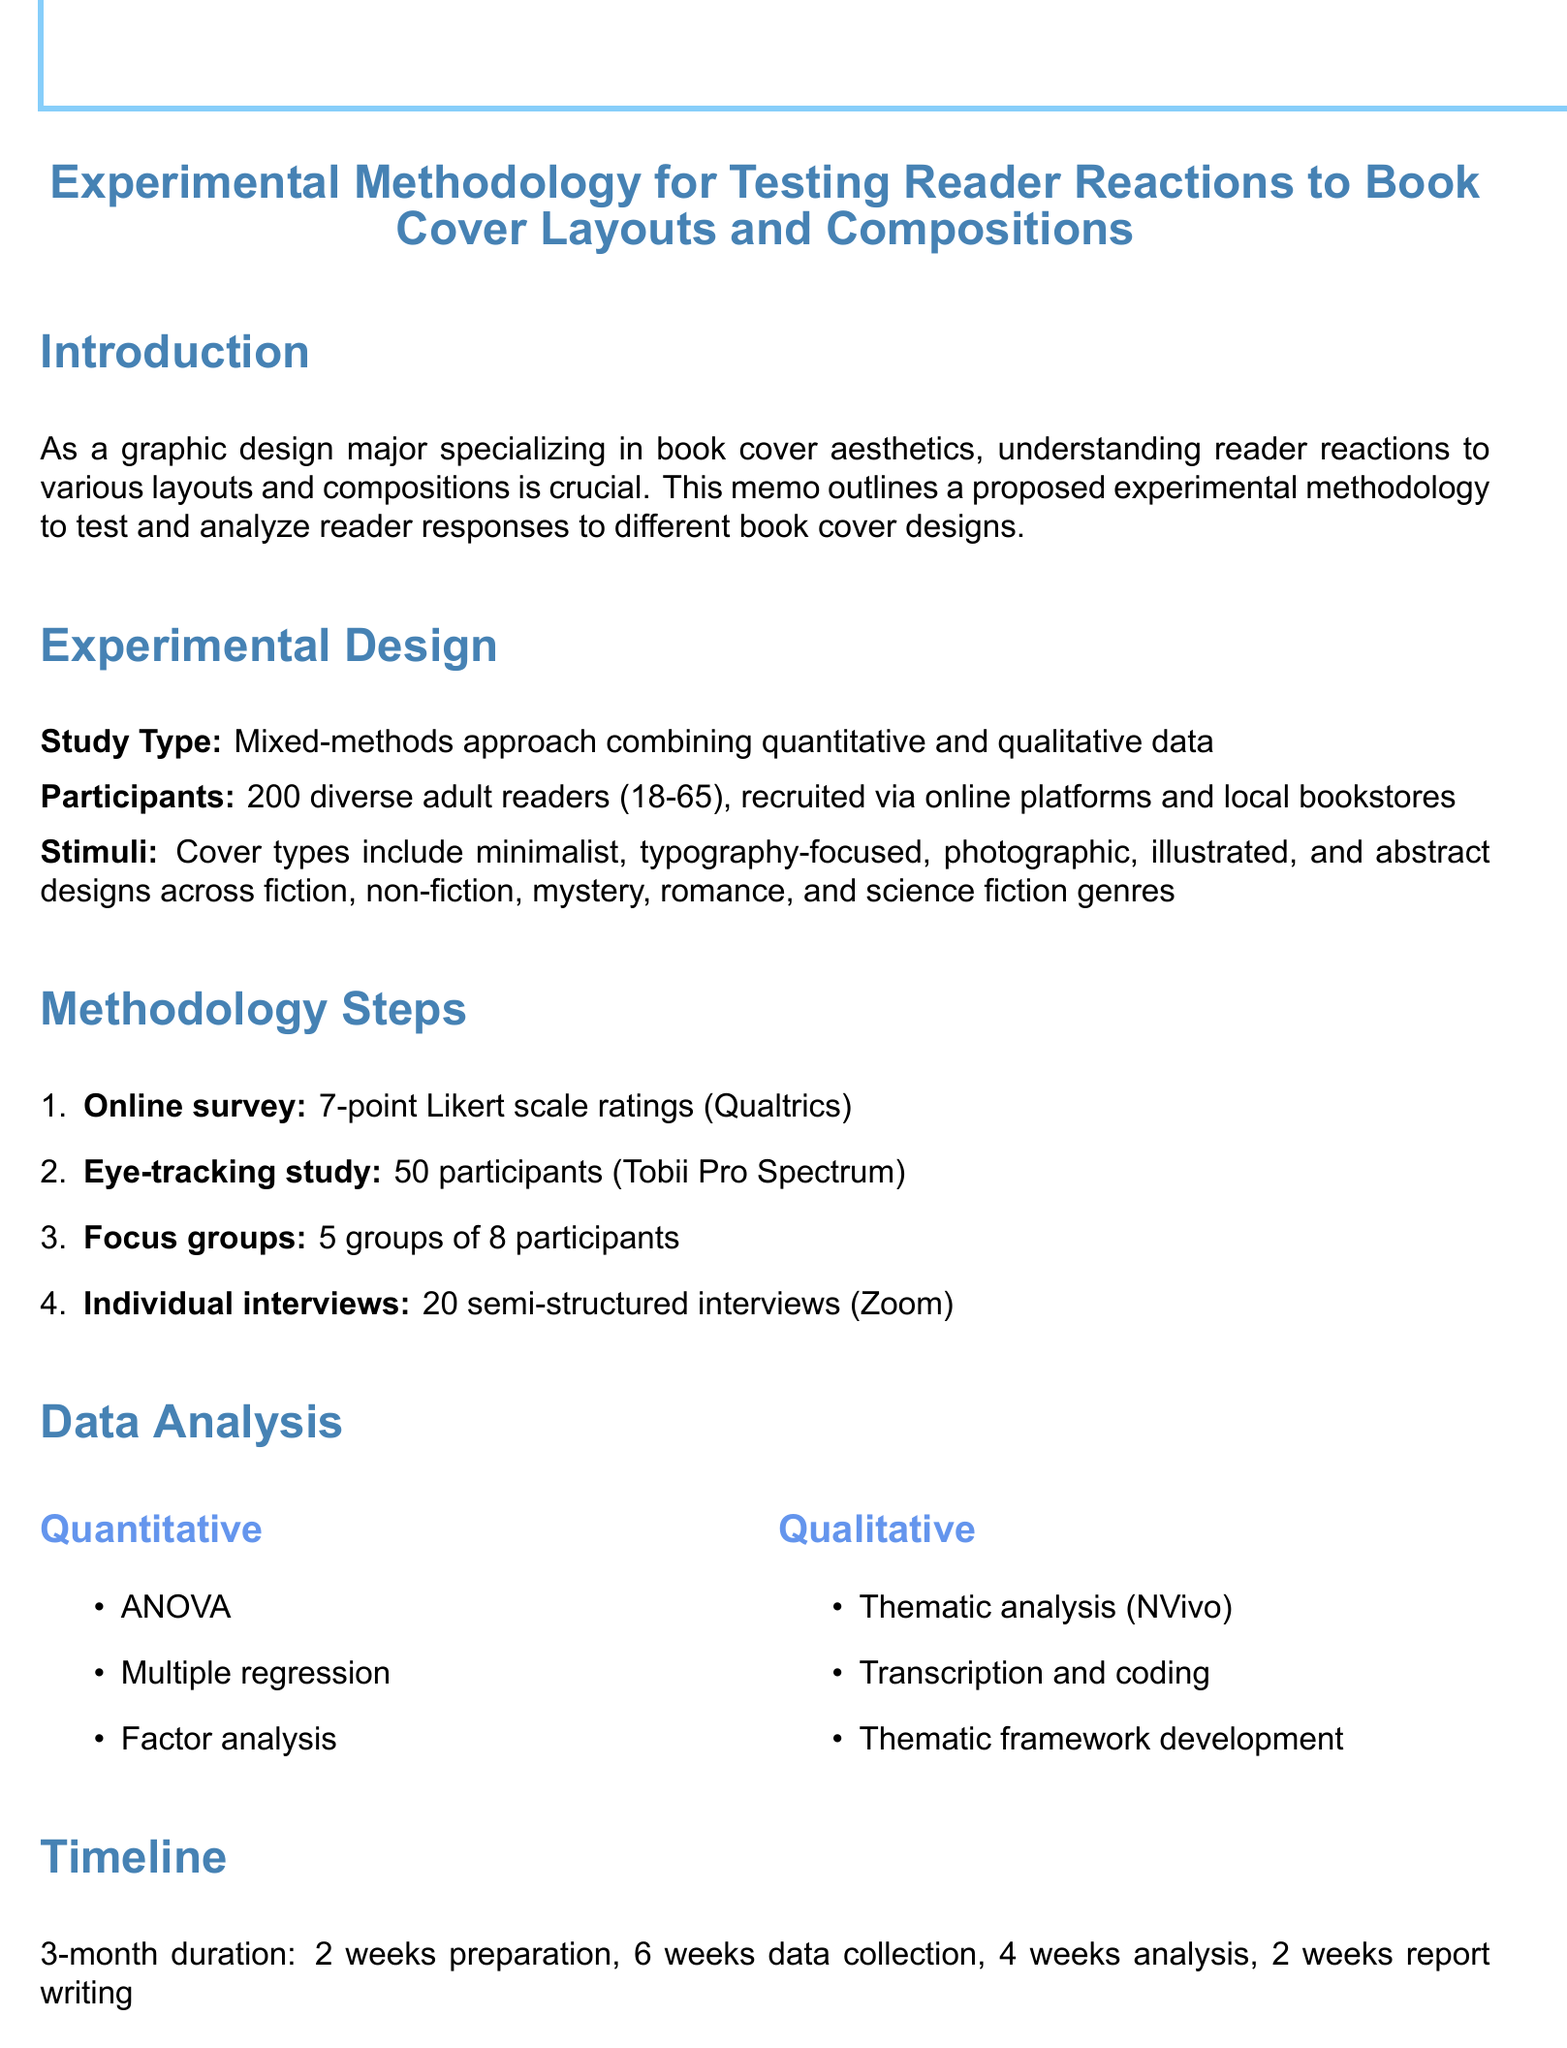What is the sample size of participants? The sample size of participants is stated in the document as part of the experimental design section.
Answer: 200 What types of covers are included in the stimuli? The document lists the different cover types under the stimuli section.
Answer: Minimalist designs, Typography-focused covers, Photographic covers, Illustrated covers, Abstract designs How long is the preparation phase scheduled to last? The timeline section specifies the duration for each phase, including preparation.
Answer: 2 weeks What software is used for qualitative analysis? The document mentions the specific software used for qualitative analysis in the data analysis section.
Answer: NVivo What method is used for eye-tracking studies? The methodology mentions the equipment used for the eye-tracking study.
Answer: Tobii Pro Spectrum What is the main purpose of the memo? The introduction clearly states the main purpose of the memo.
Answer: To test and analyze reader responses to different book cover designs How many focus groups are planned during the study? The methodology steps provide the number of focus groups planned.
Answer: 5 groups What types of analysis will be conducted for quantitative data? The document specifies the analyses included in the data analysis section.
Answer: ANOVA, Multiple regression, Factor analysis 